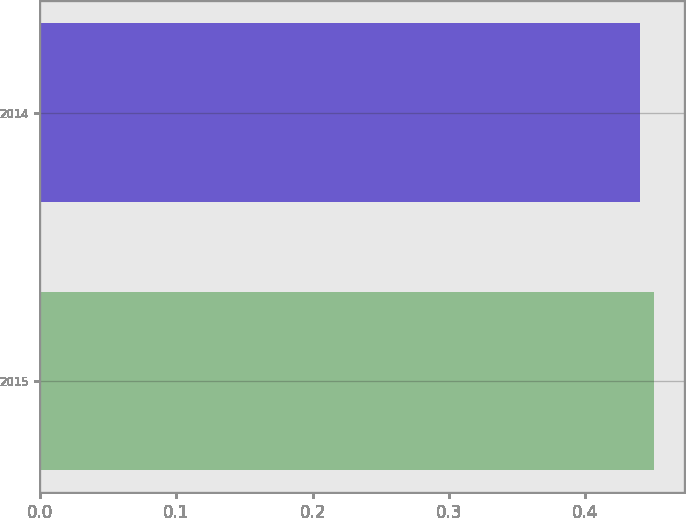<chart> <loc_0><loc_0><loc_500><loc_500><bar_chart><fcel>2015<fcel>2014<nl><fcel>0.45<fcel>0.44<nl></chart> 